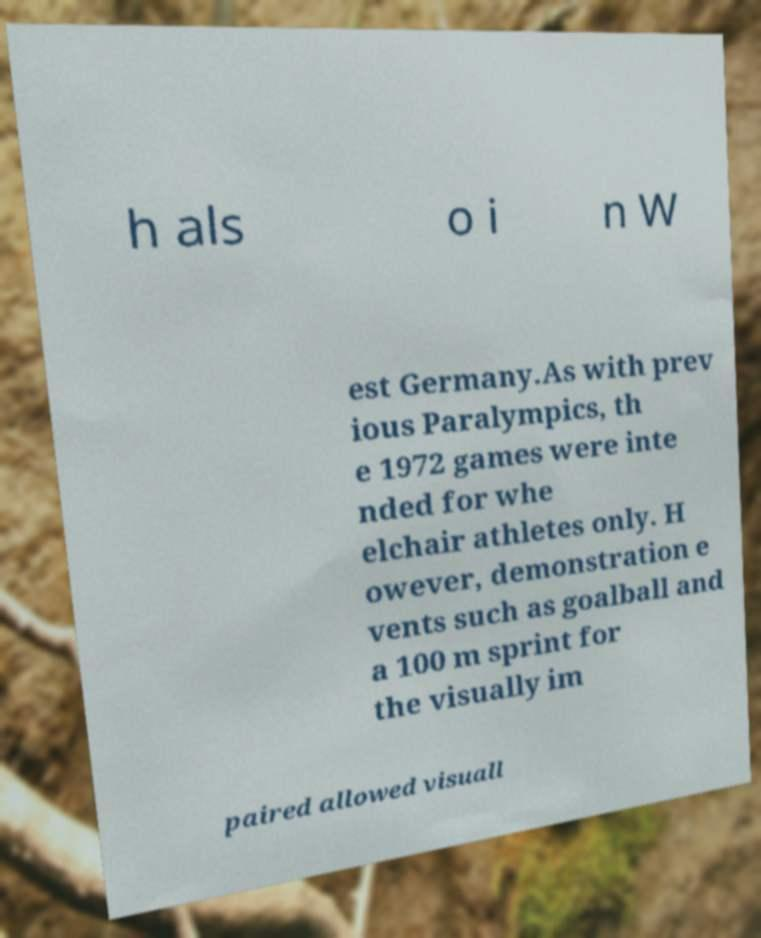Can you read and provide the text displayed in the image?This photo seems to have some interesting text. Can you extract and type it out for me? h als o i n W est Germany.As with prev ious Paralympics, th e 1972 games were inte nded for whe elchair athletes only. H owever, demonstration e vents such as goalball and a 100 m sprint for the visually im paired allowed visuall 